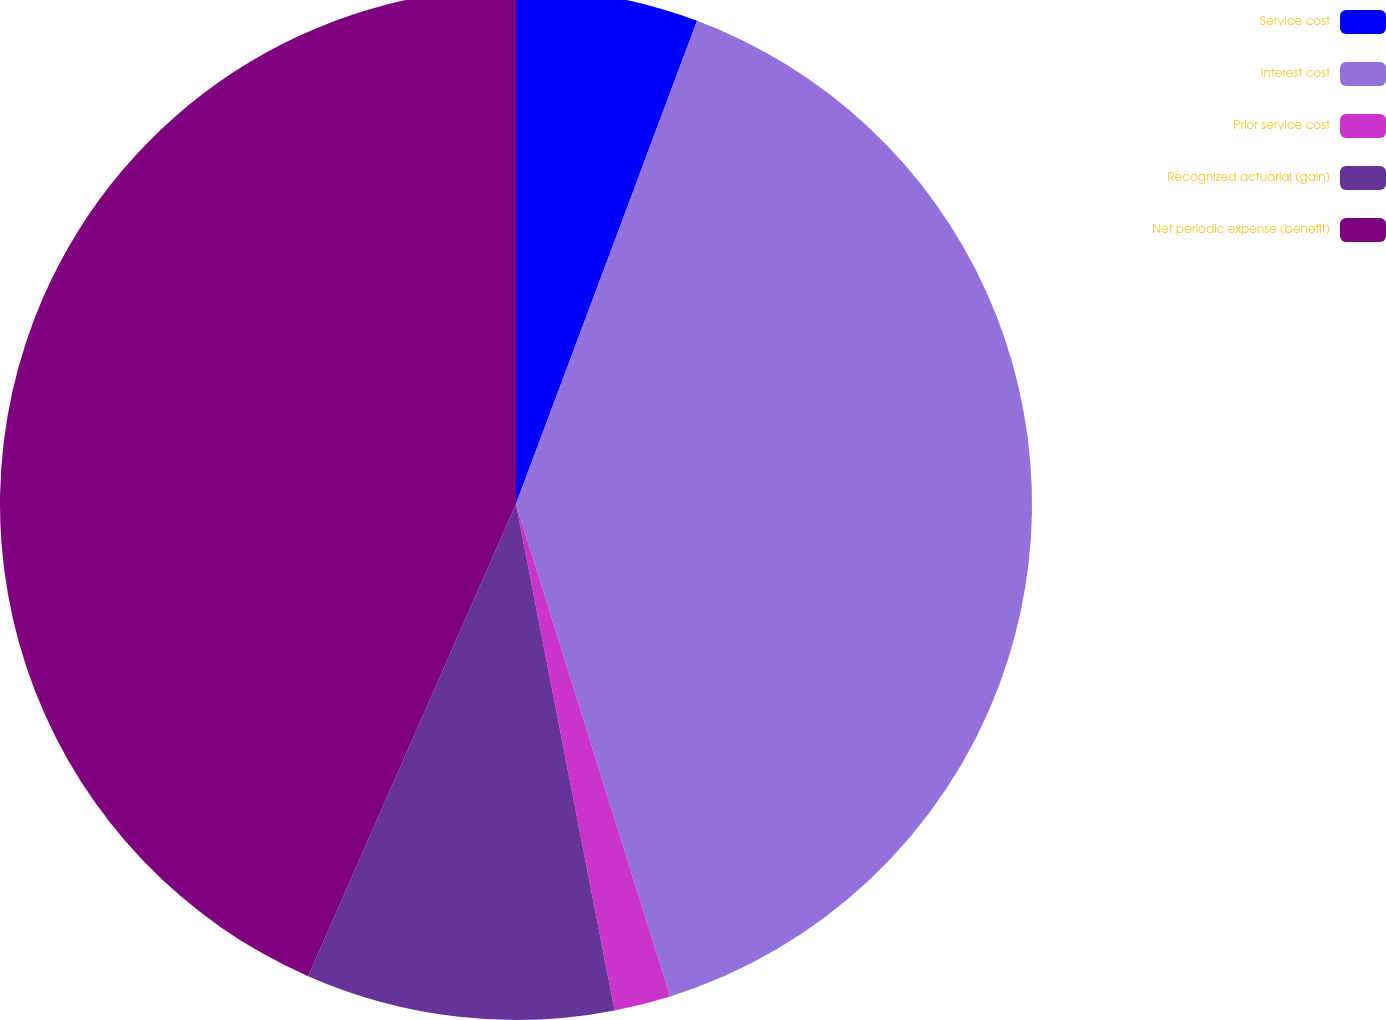Convert chart. <chart><loc_0><loc_0><loc_500><loc_500><pie_chart><fcel>Service cost<fcel>Interest cost<fcel>Prior service cost<fcel>Recognized actuarial (gain)<fcel>Net periodic expense (benefit)<nl><fcel>5.71%<fcel>39.46%<fcel>1.77%<fcel>9.66%<fcel>43.4%<nl></chart> 